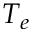<formula> <loc_0><loc_0><loc_500><loc_500>T _ { e }</formula> 